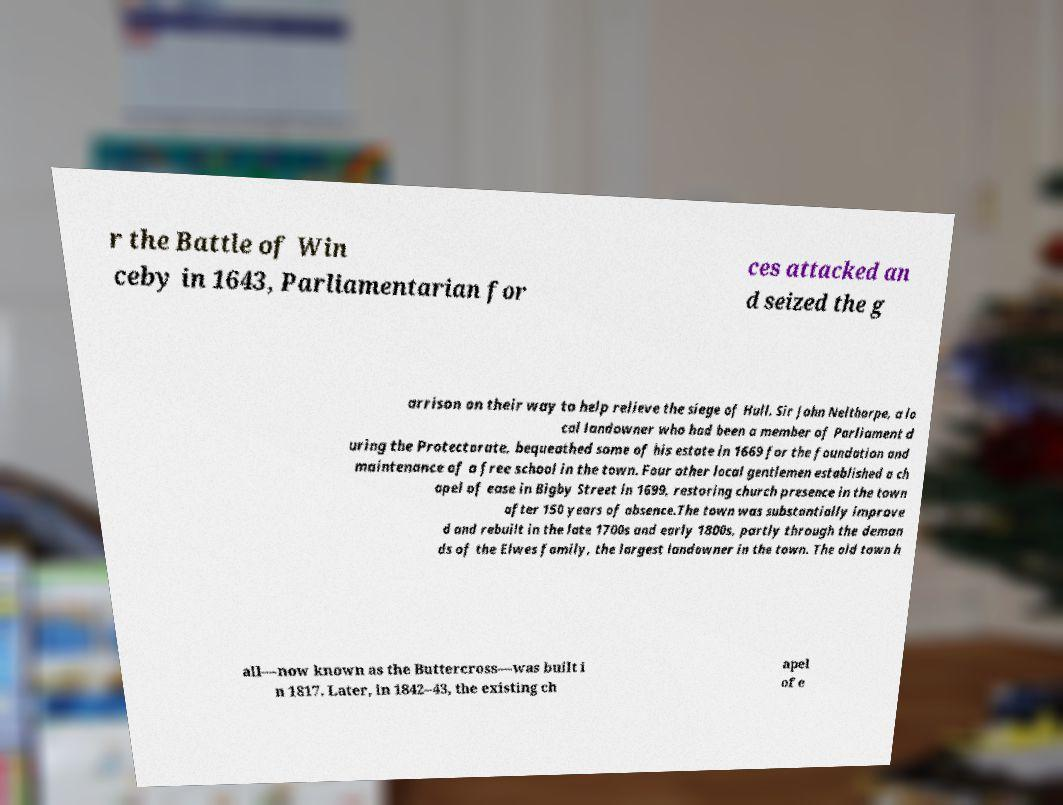Can you accurately transcribe the text from the provided image for me? r the Battle of Win ceby in 1643, Parliamentarian for ces attacked an d seized the g arrison on their way to help relieve the siege of Hull. Sir John Nelthorpe, a lo cal landowner who had been a member of Parliament d uring the Protectorate, bequeathed some of his estate in 1669 for the foundation and maintenance of a free school in the town. Four other local gentlemen established a ch apel of ease in Bigby Street in 1699, restoring church presence in the town after 150 years of absence.The town was substantially improve d and rebuilt in the late 1700s and early 1800s, partly through the deman ds of the Elwes family, the largest landowner in the town. The old town h all—now known as the Buttercross—was built i n 1817. Later, in 1842–43, the existing ch apel of e 